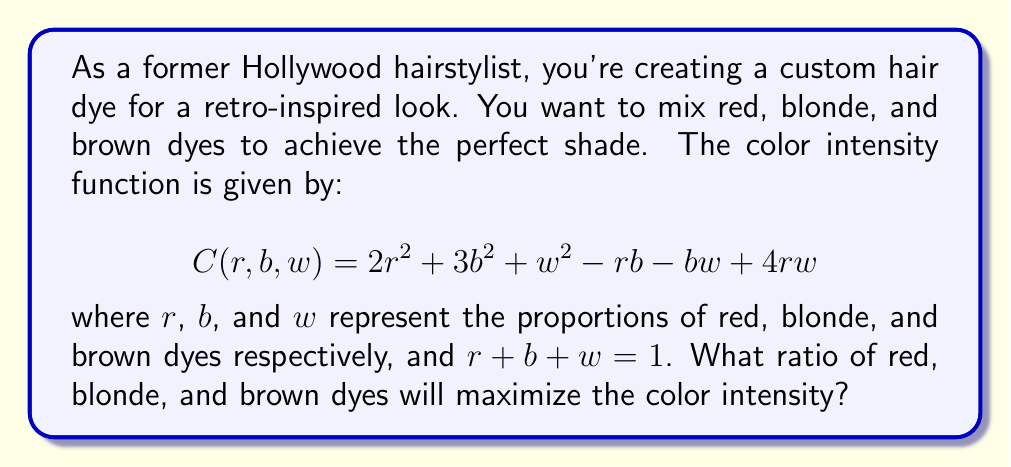What is the answer to this math problem? To find the optimal ratio, we need to maximize the function $C(r,b,w)$ subject to the constraint $r + b + w = 1$. We can use the method of Lagrange multipliers:

1) First, we set up the Lagrangian function:
   $$L(r,b,w,\lambda) = 2r^2 + 3b^2 + w^2 - rb - bw + 4rw + \lambda(r + b + w - 1)$$

2) Now, we take partial derivatives and set them equal to zero:
   $$\frac{\partial L}{\partial r} = 4r - b + 4w + \lambda = 0$$
   $$\frac{\partial L}{\partial b} = 6b - r - w + \lambda = 0$$
   $$\frac{\partial L}{\partial w} = 2w - b + 4r + \lambda = 0$$
   $$\frac{\partial L}{\partial \lambda} = r + b + w - 1 = 0$$

3) From these equations, we can deduce:
   $4r - b + 4w = 6b - r - w = 2w - b + 4r$

4) This gives us:
   $5r = 7b - 5w$ and $5r = 3w + 5b$

5) Equating these:
   $7b - 5w = 3w + 5b$
   $2b = 8w$
   $b = 4w$

6) Substituting this into $r + b + w = 1$:
   $r + 4w + w = 1$
   $r + 5w = 1$

7) From step 4, we know $5r = 3w + 5b = 3w + 20w = 23w$
   So, $r = \frac{23}{5}w$

8) Substituting this into $r + 5w = 1$:
   $\frac{23}{5}w + 5w = 1$
   $\frac{48}{5}w = 1$
   $w = \frac{5}{48}$

9) Now we can find $r$ and $b$:
   $r = \frac{23}{5} \cdot \frac{5}{48} = \frac{23}{48}$
   $b = 4w = 4 \cdot \frac{5}{48} = \frac{5}{12}$

Therefore, the optimal ratio is $\frac{23}{48}$ red, $\frac{5}{12}$ blonde, and $\frac{5}{48}$ brown.
Answer: The optimal ratio of red:blonde:brown dyes is $23:20:5$ or approximately $0.479 : 0.417 : 0.104$. 